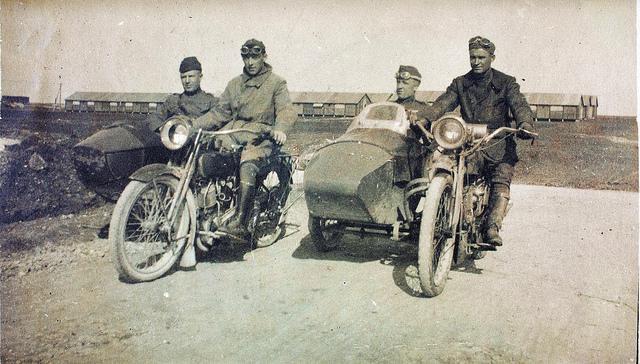How many people are there?
Give a very brief answer. 3. How many motorcycles are there?
Give a very brief answer. 2. 